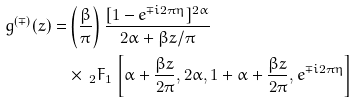<formula> <loc_0><loc_0><loc_500><loc_500>g ^ { ( \mp ) } ( z ) = & \left ( \frac { \beta } { \pi } \right ) \frac { [ 1 - e ^ { \mp i 2 \pi \eta } ] ^ { 2 \alpha } } { 2 \alpha + \beta z / \pi } \\ & \times \ _ { 2 } F _ { 1 } \left [ \alpha + \frac { \beta z } { 2 \pi } , 2 \alpha , 1 + \alpha + \frac { \beta z } { 2 \pi } , e ^ { \mp i 2 \pi \eta } \right ]</formula> 